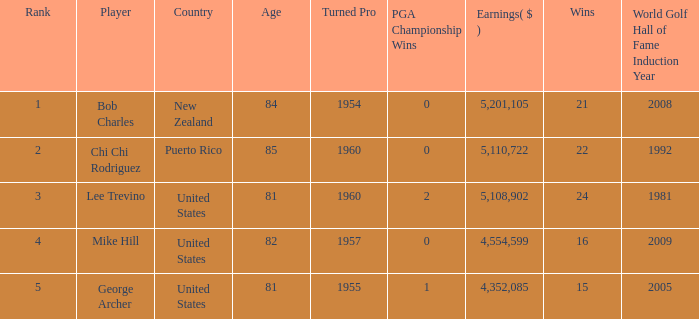In total, how much did the United States player George Archer earn with Wins lower than 24 and a rank that was higher than 5? 0.0. 